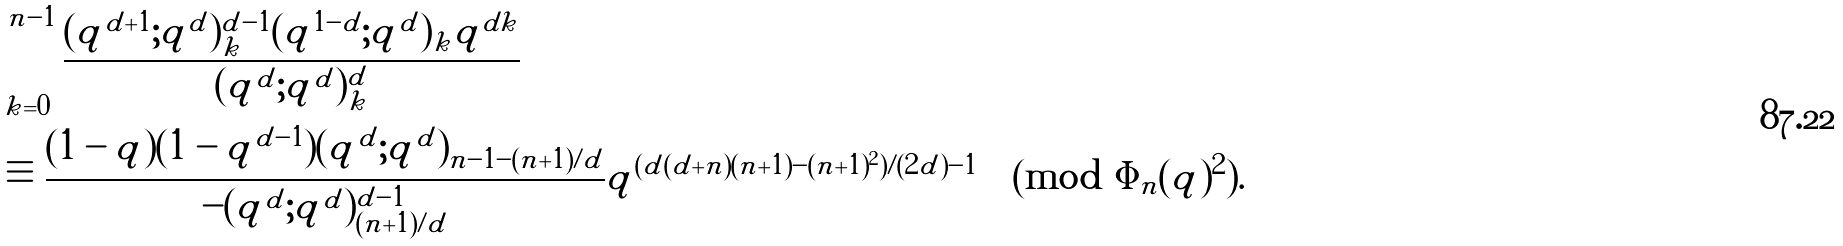<formula> <loc_0><loc_0><loc_500><loc_500>& \sum _ { k = 0 } ^ { n - 1 } \frac { ( q ^ { d + 1 } ; q ^ { d } ) _ { k } ^ { d - 1 } ( q ^ { 1 - d } ; q ^ { d } ) _ { k } q ^ { d k } } { ( q ^ { d } ; q ^ { d } ) _ { k } ^ { d } } \\ & \equiv \frac { ( 1 - q ) ( 1 - q ^ { d - 1 } ) ( q ^ { d } ; q ^ { d } ) _ { n - 1 - ( n + 1 ) / d } } { - ( q ^ { d } ; q ^ { d } ) _ { ( n + 1 ) / d } ^ { d - 1 } } q ^ { ( d ( d + n ) ( n + 1 ) - ( n + 1 ) ^ { 2 } ) / ( 2 d ) - 1 } \pmod { \Phi _ { n } ( q ) ^ { 2 } } .</formula> 